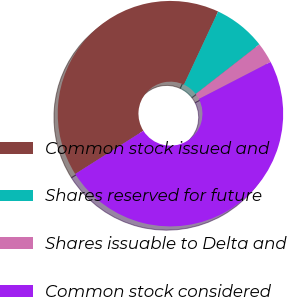Convert chart. <chart><loc_0><loc_0><loc_500><loc_500><pie_chart><fcel>Common stock issued and<fcel>Shares reserved for future<fcel>Shares issuable to Delta and<fcel>Common stock considered<nl><fcel>40.94%<fcel>7.51%<fcel>2.95%<fcel>48.6%<nl></chart> 